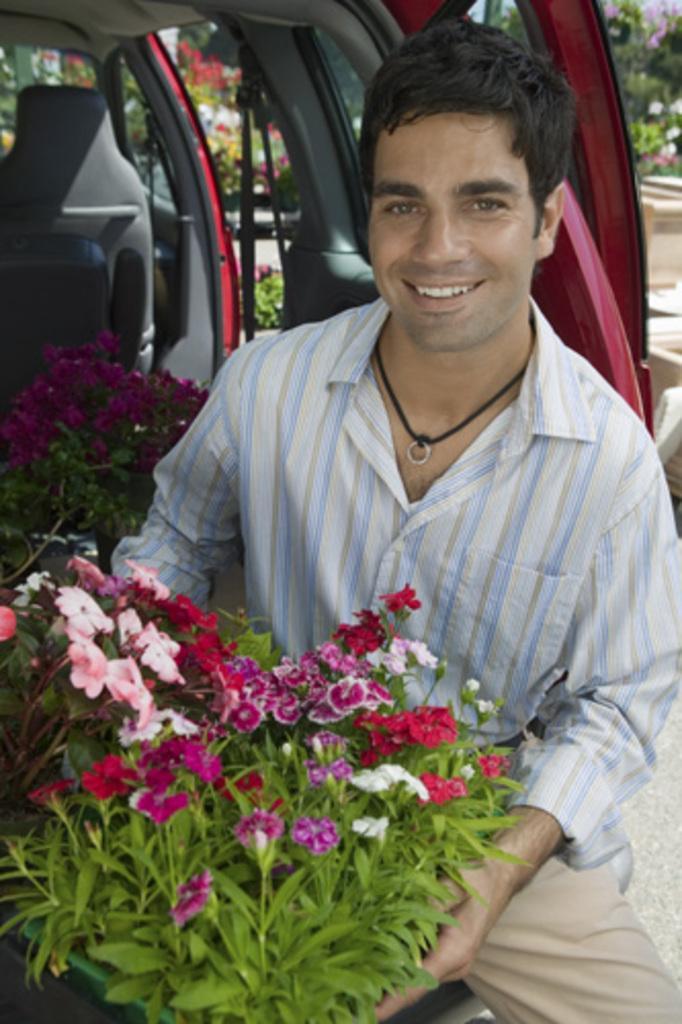Could you give a brief overview of what you see in this image? In this picture we can see a man smiling, plants with flowers, vehicle and in the background we can see trees and some objects. 